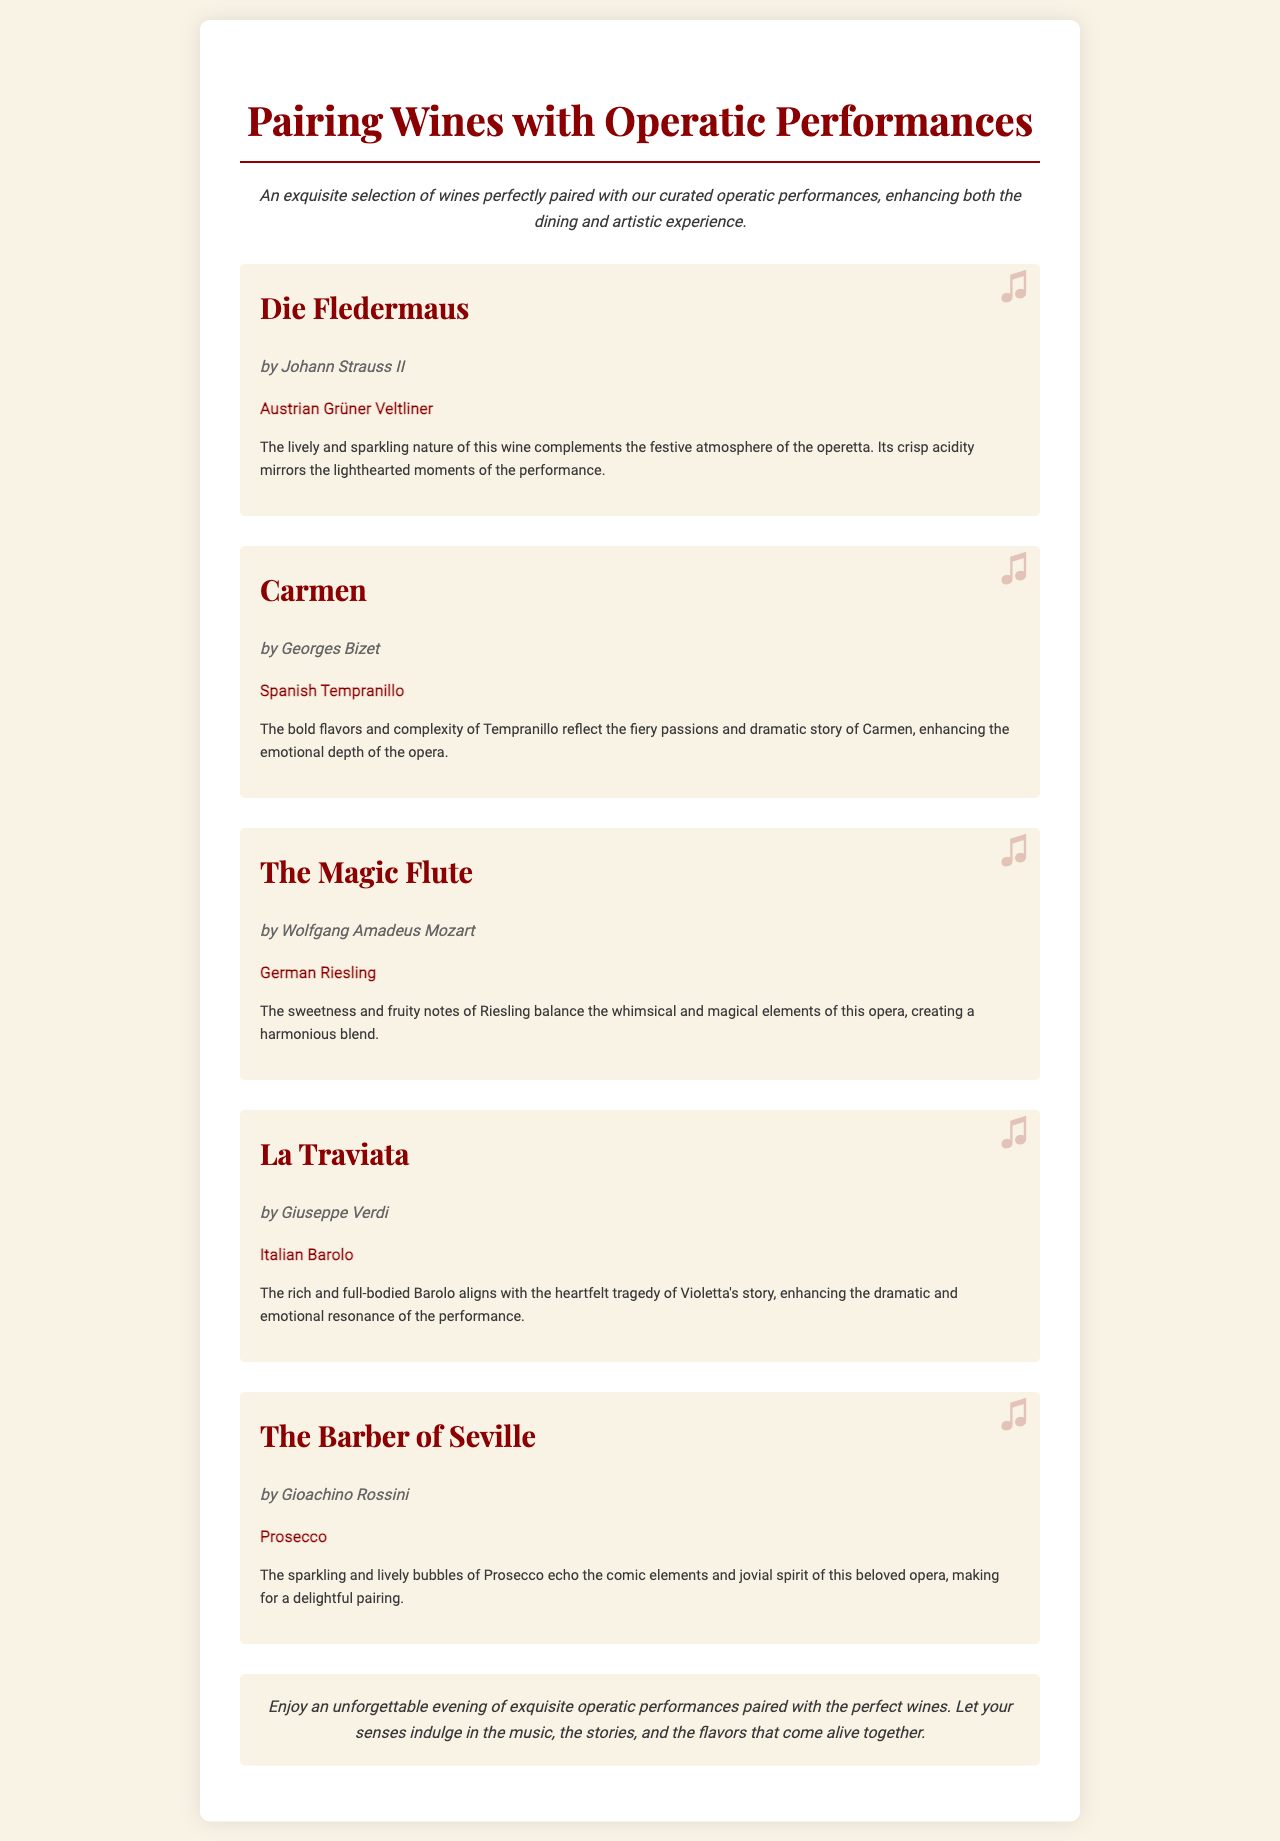What wine is paired with Die Fledermaus? The wine listed for Die Fledermaus is Austrian Grüner Veltliner.
Answer: Austrian Grüner Veltliner Who composed The Magic Flute? The composer of The Magic Flute is Wolfgang Amadeus Mozart.
Answer: Wolfgang Amadeus Mozart What is the flavor profile of the wine paired with Carmen? The Spanish Tempranillo is characterized by bold flavors and complexity.
Answer: Bold flavors and complexity How does the wine pairing enhance the experience of La Traviata? The Barolo's richness aligns with the heartfelt tragedy of Violetta's story, enhancing dramatic resonance.
Answer: Enhances dramatic resonance Which operatic performance is paired with Prosecco? The Barber of Seville is paired with Prosecco.
Answer: The Barber of Seville What type of wine complements the whimsical elements of The Magic Flute? German Riesling complements the whimsical elements.
Answer: German Riesling What mood does the Austrian Grüner Veltliner reflect during Die Fledermaus? It reflects a lively and sparkling mood.
Answer: Lively and sparkling mood What is the conclusion of the document? The conclusion emphasizes an unforgettable evening of operatic performances and perfect wine pairings.
Answer: An unforgettable evening of operatic performances and perfect wine pairings 